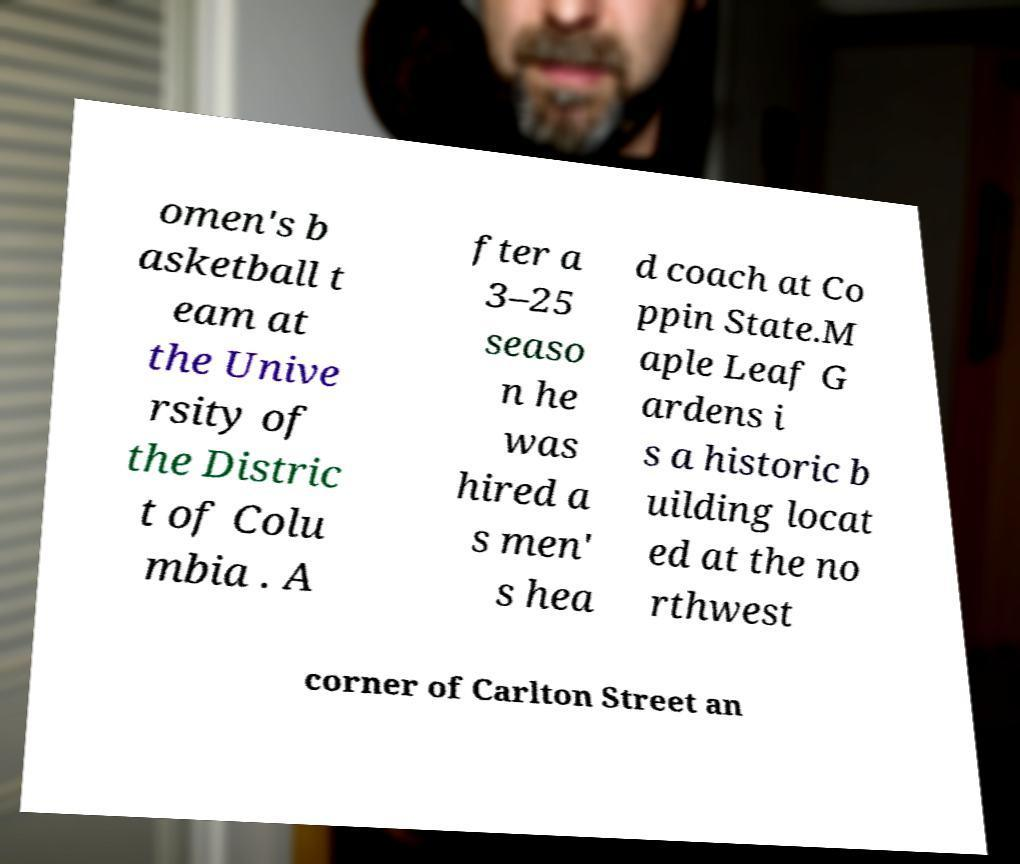Please read and relay the text visible in this image. What does it say? omen's b asketball t eam at the Unive rsity of the Distric t of Colu mbia . A fter a 3–25 seaso n he was hired a s men' s hea d coach at Co ppin State.M aple Leaf G ardens i s a historic b uilding locat ed at the no rthwest corner of Carlton Street an 